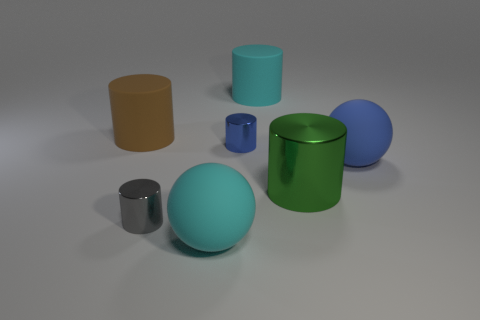Subtract all brown cylinders. How many cylinders are left? 4 Subtract all big metal cylinders. How many cylinders are left? 4 Subtract all yellow cylinders. Subtract all gray balls. How many cylinders are left? 5 Add 3 green shiny cylinders. How many objects exist? 10 Subtract all cylinders. How many objects are left? 2 Subtract 0 gray cubes. How many objects are left? 7 Subtract all big cylinders. Subtract all small yellow matte cylinders. How many objects are left? 4 Add 7 large cyan rubber cylinders. How many large cyan rubber cylinders are left? 8 Add 4 blue metal objects. How many blue metal objects exist? 5 